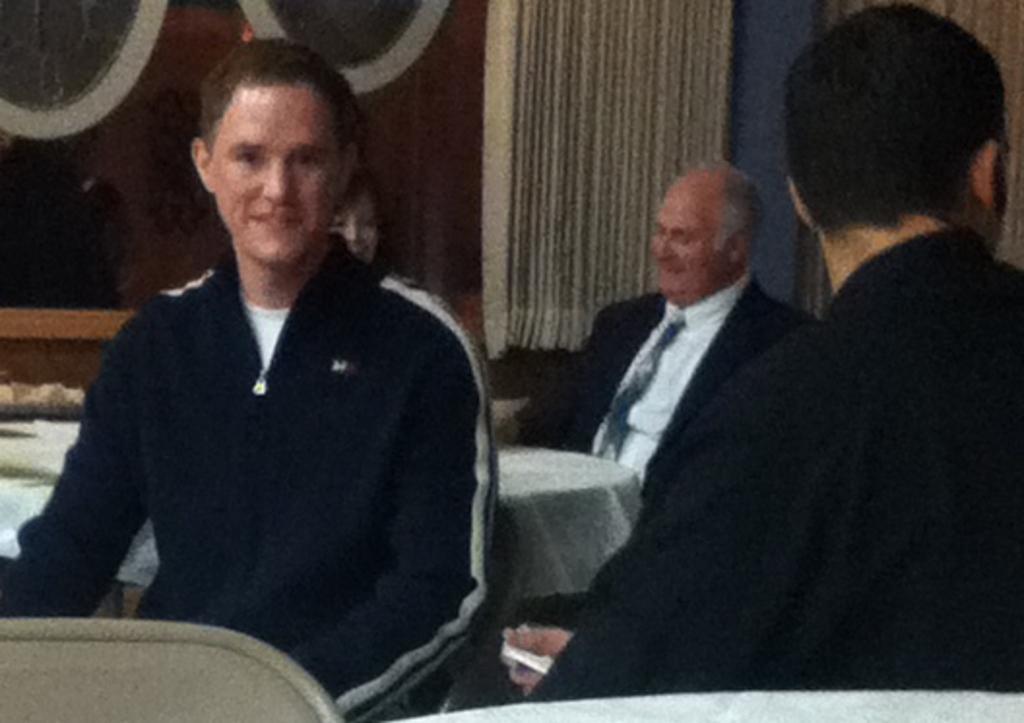In one or two sentences, can you explain what this image depicts? In this image on the left, there is a man, he wears a jacket. On the right there is a man, he wears a t shirt. In the middle there is a man, he wears a suit, shirt, tie, in front of him there is a table. At the bottom there is a table and chair. In the background there are curtains, cables and cloth. 